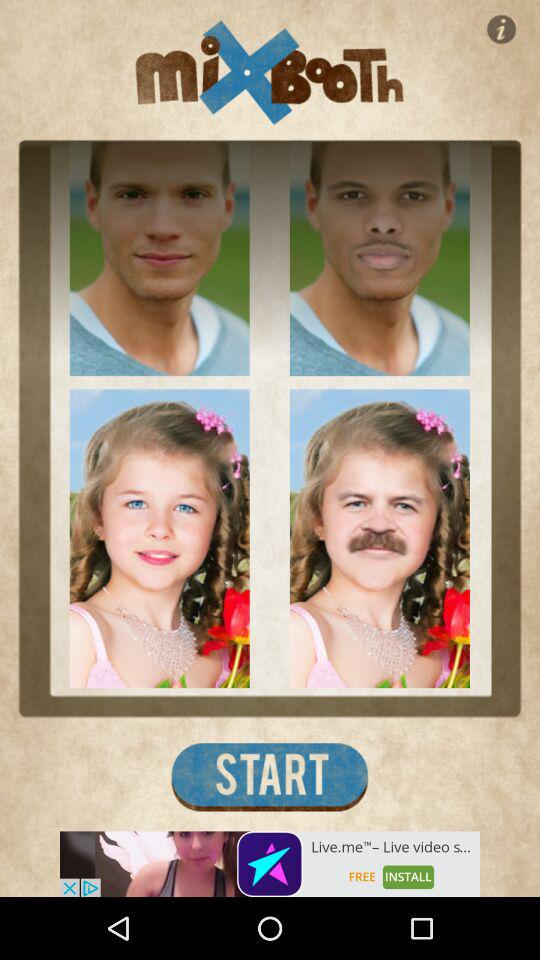What is the name of the application? The name of the application is "miXBooTh". 